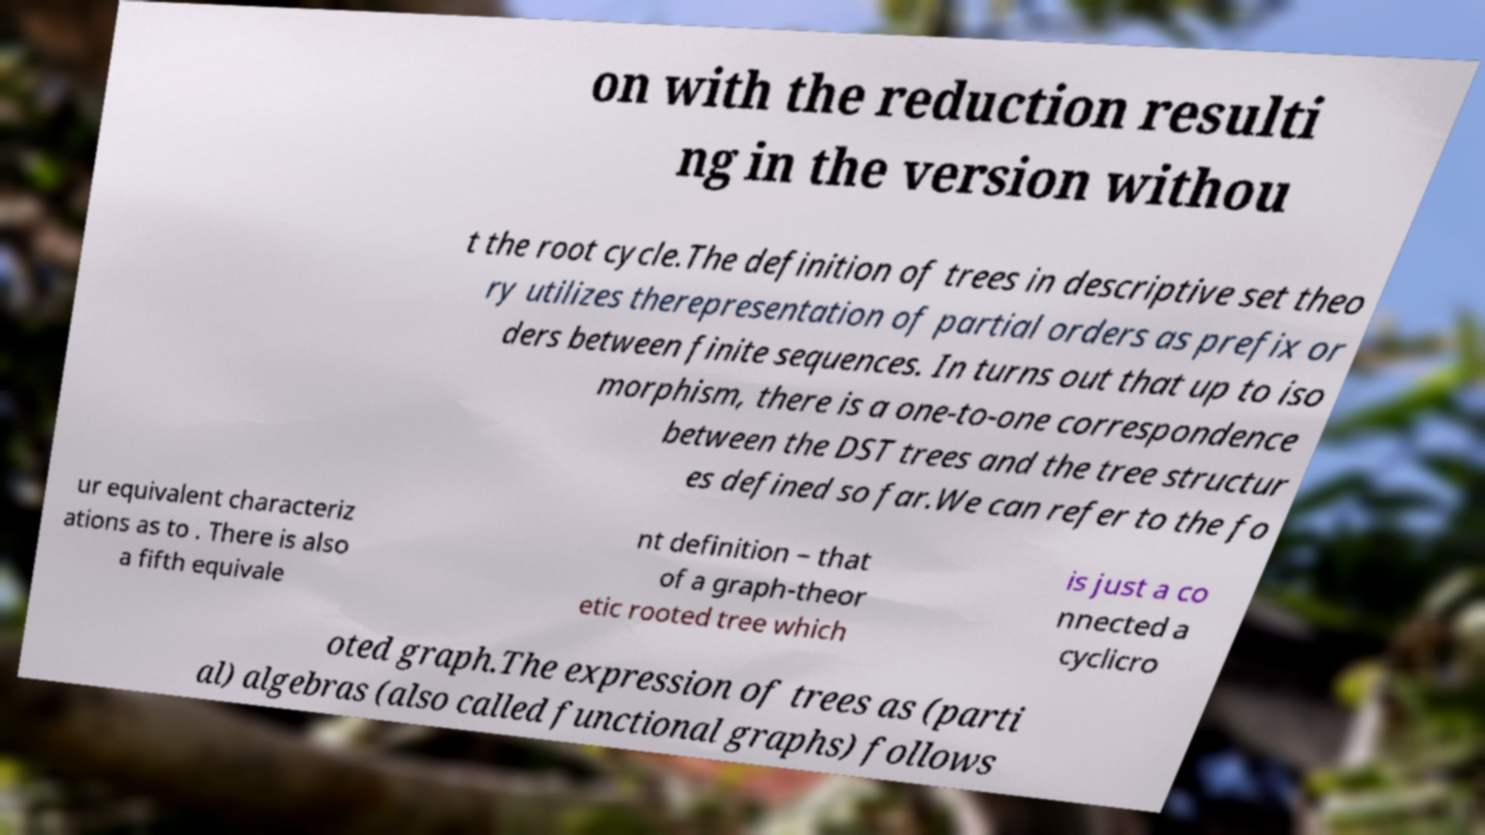What messages or text are displayed in this image? I need them in a readable, typed format. on with the reduction resulti ng in the version withou t the root cycle.The definition of trees in descriptive set theo ry utilizes therepresentation of partial orders as prefix or ders between finite sequences. In turns out that up to iso morphism, there is a one-to-one correspondence between the DST trees and the tree structur es defined so far.We can refer to the fo ur equivalent characteriz ations as to . There is also a fifth equivale nt definition – that of a graph-theor etic rooted tree which is just a co nnected a cyclicro oted graph.The expression of trees as (parti al) algebras (also called functional graphs) follows 